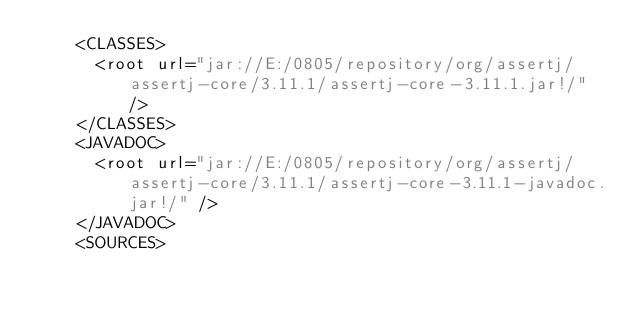<code> <loc_0><loc_0><loc_500><loc_500><_XML_>    <CLASSES>
      <root url="jar://E:/0805/repository/org/assertj/assertj-core/3.11.1/assertj-core-3.11.1.jar!/" />
    </CLASSES>
    <JAVADOC>
      <root url="jar://E:/0805/repository/org/assertj/assertj-core/3.11.1/assertj-core-3.11.1-javadoc.jar!/" />
    </JAVADOC>
    <SOURCES></code> 